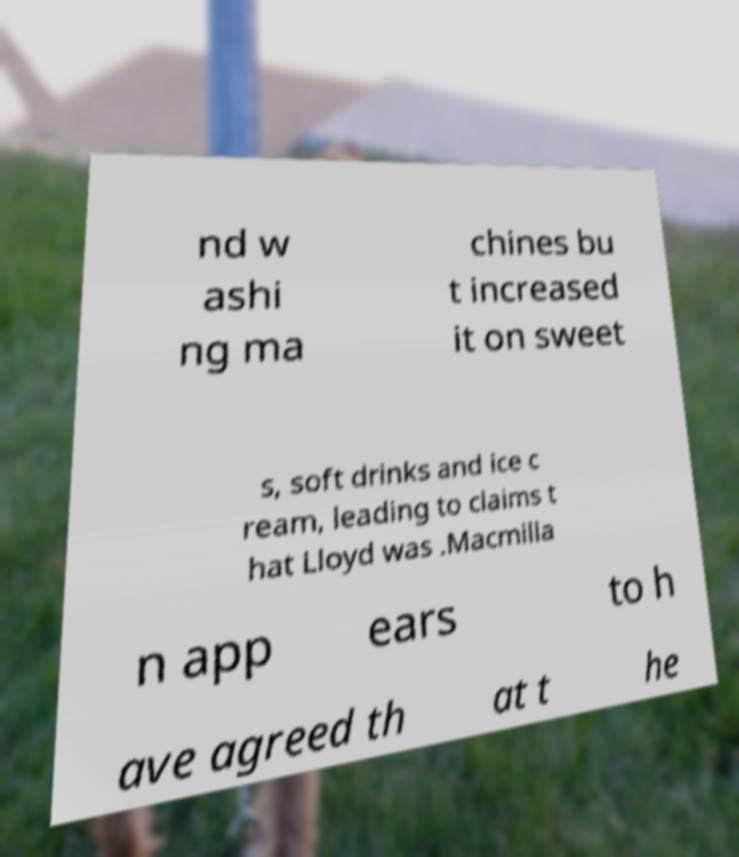For documentation purposes, I need the text within this image transcribed. Could you provide that? nd w ashi ng ma chines bu t increased it on sweet s, soft drinks and ice c ream, leading to claims t hat Lloyd was .Macmilla n app ears to h ave agreed th at t he 